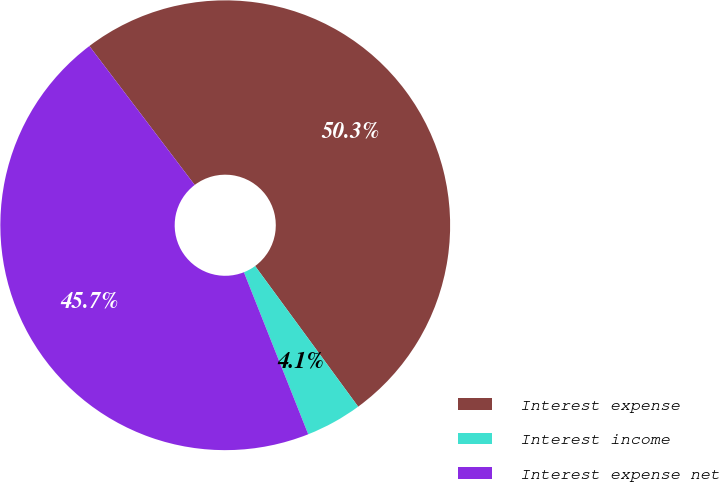<chart> <loc_0><loc_0><loc_500><loc_500><pie_chart><fcel>Interest expense<fcel>Interest income<fcel>Interest expense net<nl><fcel>50.26%<fcel>4.05%<fcel>45.69%<nl></chart> 